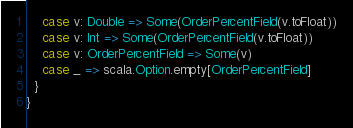<code> <loc_0><loc_0><loc_500><loc_500><_Scala_>    case v: Double => Some(OrderPercentField(v.toFloat))
    case v: Int => Some(OrderPercentField(v.toFloat))
    case v: OrderPercentField => Some(v)
    case _ => scala.Option.empty[OrderPercentField]
  } 
}
</code> 